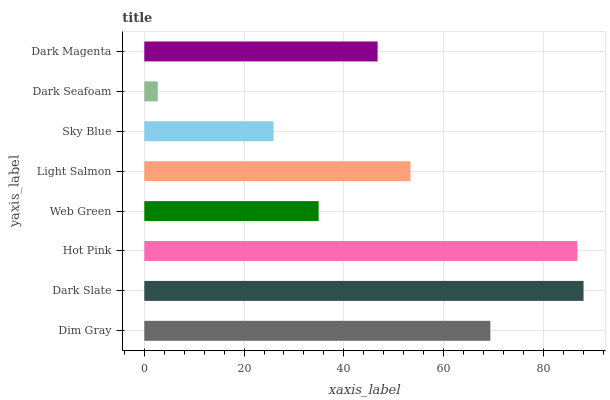Is Dark Seafoam the minimum?
Answer yes or no. Yes. Is Dark Slate the maximum?
Answer yes or no. Yes. Is Hot Pink the minimum?
Answer yes or no. No. Is Hot Pink the maximum?
Answer yes or no. No. Is Dark Slate greater than Hot Pink?
Answer yes or no. Yes. Is Hot Pink less than Dark Slate?
Answer yes or no. Yes. Is Hot Pink greater than Dark Slate?
Answer yes or no. No. Is Dark Slate less than Hot Pink?
Answer yes or no. No. Is Light Salmon the high median?
Answer yes or no. Yes. Is Dark Magenta the low median?
Answer yes or no. Yes. Is Dark Seafoam the high median?
Answer yes or no. No. Is Hot Pink the low median?
Answer yes or no. No. 